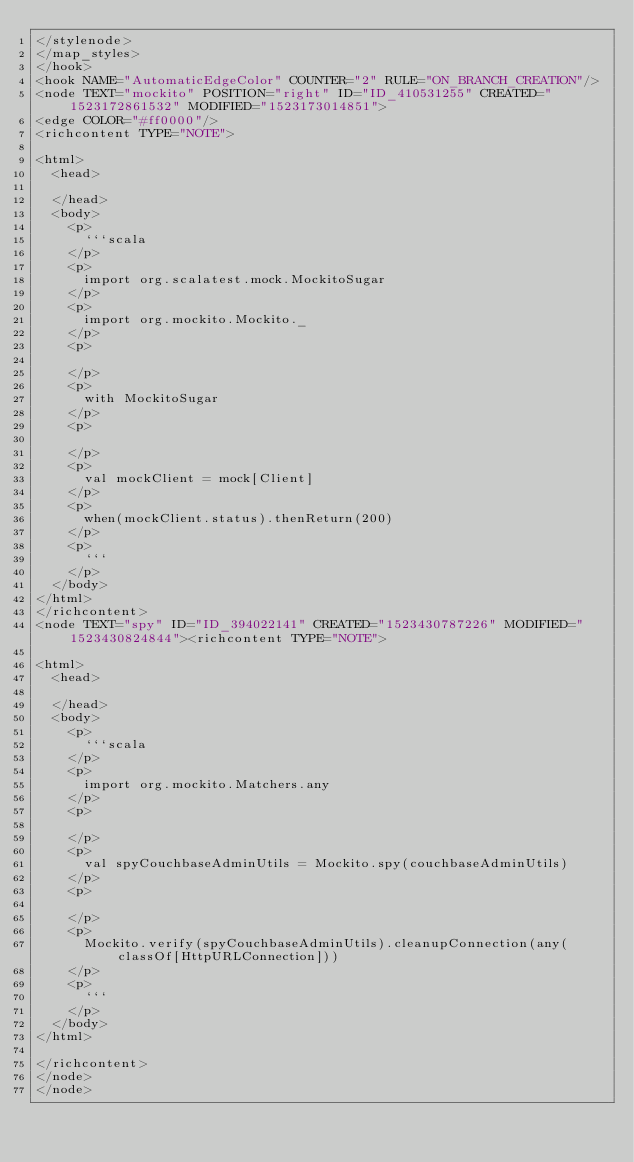<code> <loc_0><loc_0><loc_500><loc_500><_ObjectiveC_></stylenode>
</map_styles>
</hook>
<hook NAME="AutomaticEdgeColor" COUNTER="2" RULE="ON_BRANCH_CREATION"/>
<node TEXT="mockito" POSITION="right" ID="ID_410531255" CREATED="1523172861532" MODIFIED="1523173014851">
<edge COLOR="#ff0000"/>
<richcontent TYPE="NOTE">

<html>
  <head>
    
  </head>
  <body>
    <p>
      ```scala
    </p>
    <p>
      import org.scalatest.mock.MockitoSugar
    </p>
    <p>
      import org.mockito.Mockito._
    </p>
    <p>
      
    </p>
    <p>
      with MockitoSugar
    </p>
    <p>
      
    </p>
    <p>
      val mockClient = mock[Client]
    </p>
    <p>
      when(mockClient.status).thenReturn(200)
    </p>
    <p>
      ```
    </p>
  </body>
</html>
</richcontent>
<node TEXT="spy" ID="ID_394022141" CREATED="1523430787226" MODIFIED="1523430824844"><richcontent TYPE="NOTE">

<html>
  <head>
    
  </head>
  <body>
    <p>
      ```scala
    </p>
    <p>
      import org.mockito.Matchers.any
    </p>
    <p>
      
    </p>
    <p>
      val spyCouchbaseAdminUtils = Mockito.spy(couchbaseAdminUtils)
    </p>
    <p>
      
    </p>
    <p>
      Mockito.verify(spyCouchbaseAdminUtils).cleanupConnection(any(classOf[HttpURLConnection]))
    </p>
    <p>
      ```
    </p>
  </body>
</html>

</richcontent>
</node>
</node></code> 